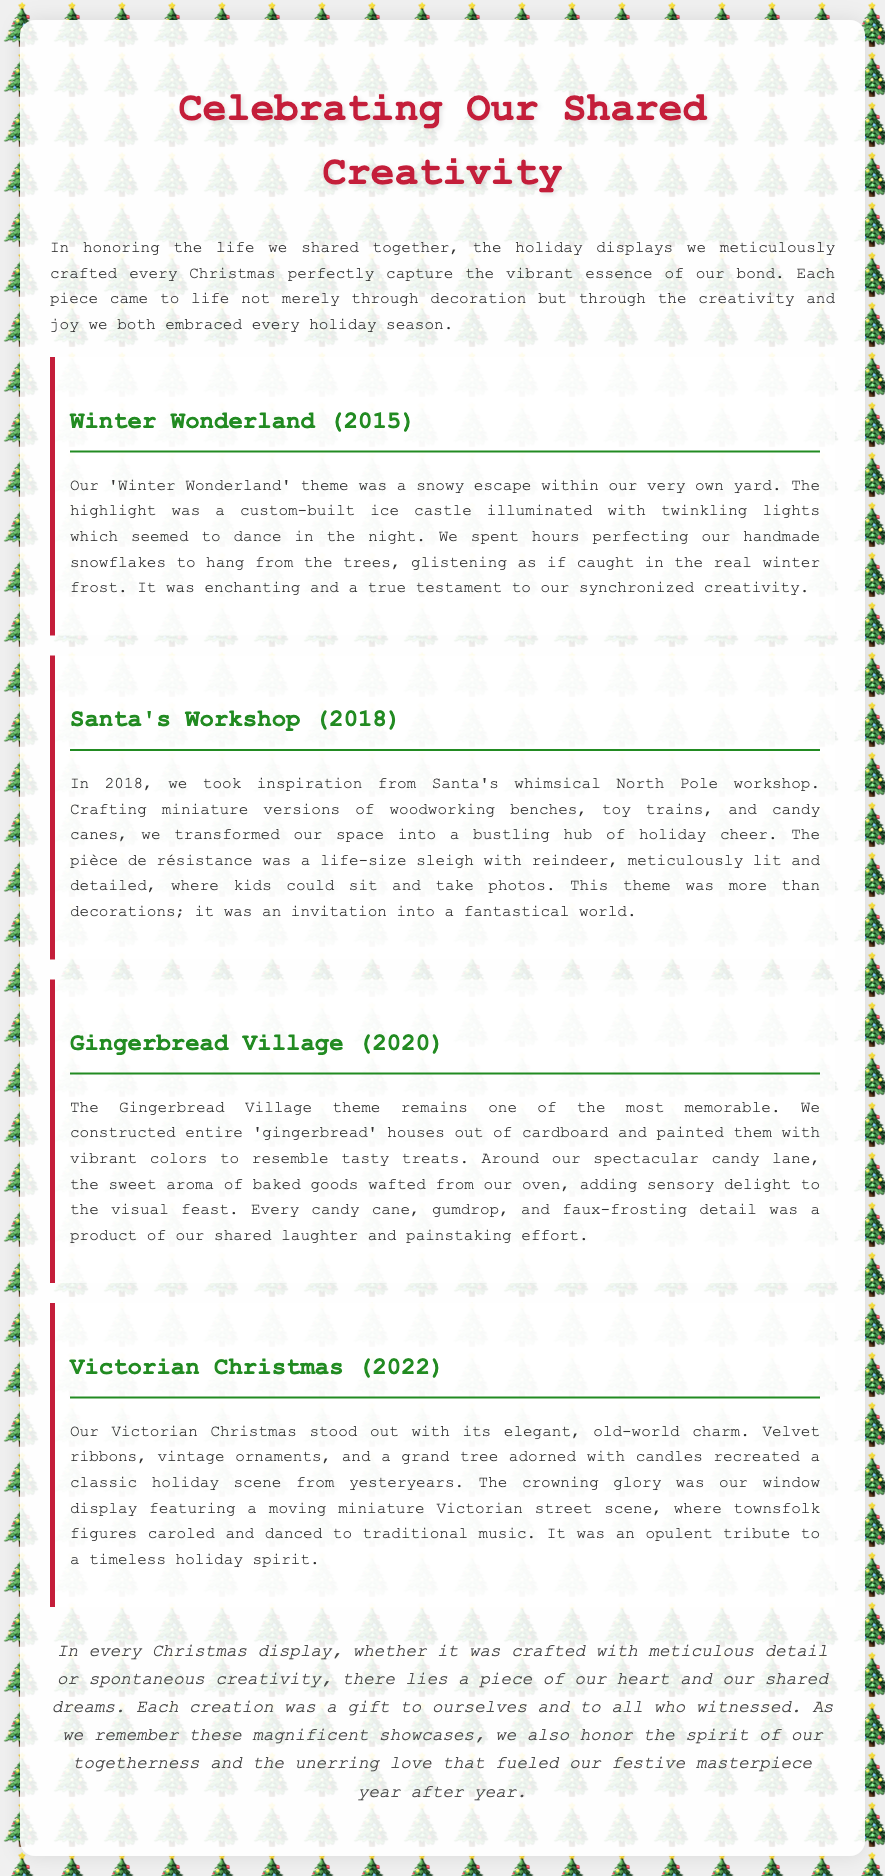What year was the Winter Wonderland theme? The year of the Winter Wonderland theme is explicitly stated in the document as 2015.
Answer: 2015 What was the highlight of the Santa's Workshop theme? The document describes the highlight as a life-size sleigh with reindeer, meticulously lit and detailed.
Answer: Life-size sleigh with reindeer How were the gingerbread houses created? The document states that the gingerbread houses were constructed out of cardboard and painted with vibrant colors.
Answer: Cardboard What was featured in the Victorian Christmas window display? The window display featured a moving miniature Victorian street scene where townsfolk figures caroled and danced.
Answer: Moving miniature Victorian street scene What two elements characterized the Winter Wonderland theme? The elements highlighted in the document for the Winter Wonderland theme are a custom-built ice castle and handmade snowflakes.
Answer: Ice castle and snowflakes What sensory delight was included in the Gingerbread Village? The text mentions the sweet aroma of baked goods wafting from the oven, which added sensory delight.
Answer: Sweet aroma of baked goods What did the Victorian Christmas theme recreate? The Victorian Christmas theme recreated a classic holiday scene from yesteryears.
Answer: Classic holiday scene In what year did the Gingerbread Village theme take place? The document specifies that the Gingerbread Village theme was in 2020.
Answer: 2020 